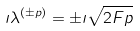Convert formula to latex. <formula><loc_0><loc_0><loc_500><loc_500>\imath \lambda ^ { ( \pm p ) } = \pm \imath \sqrt { 2 F p }</formula> 